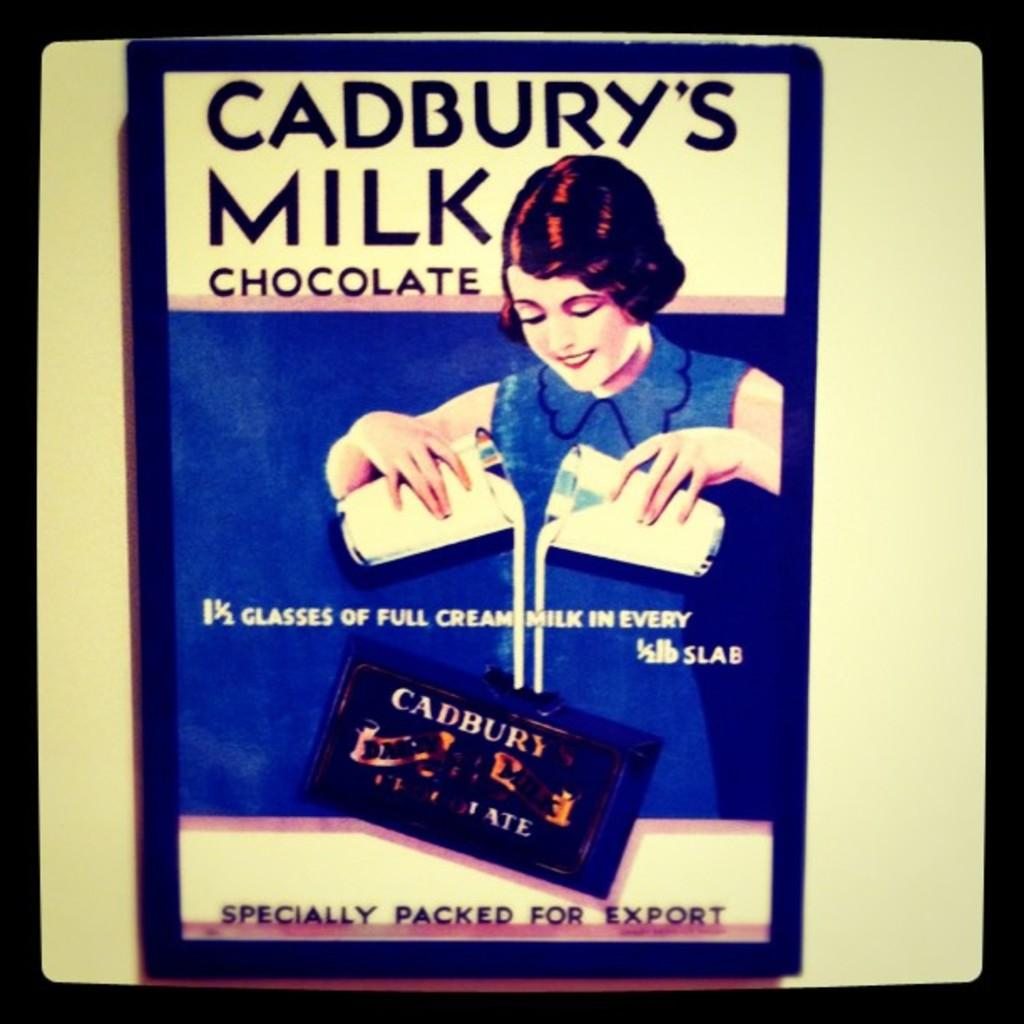<image>
Write a terse but informative summary of the picture. An old advertisement for Cadbury's Milk featuring a woman. 